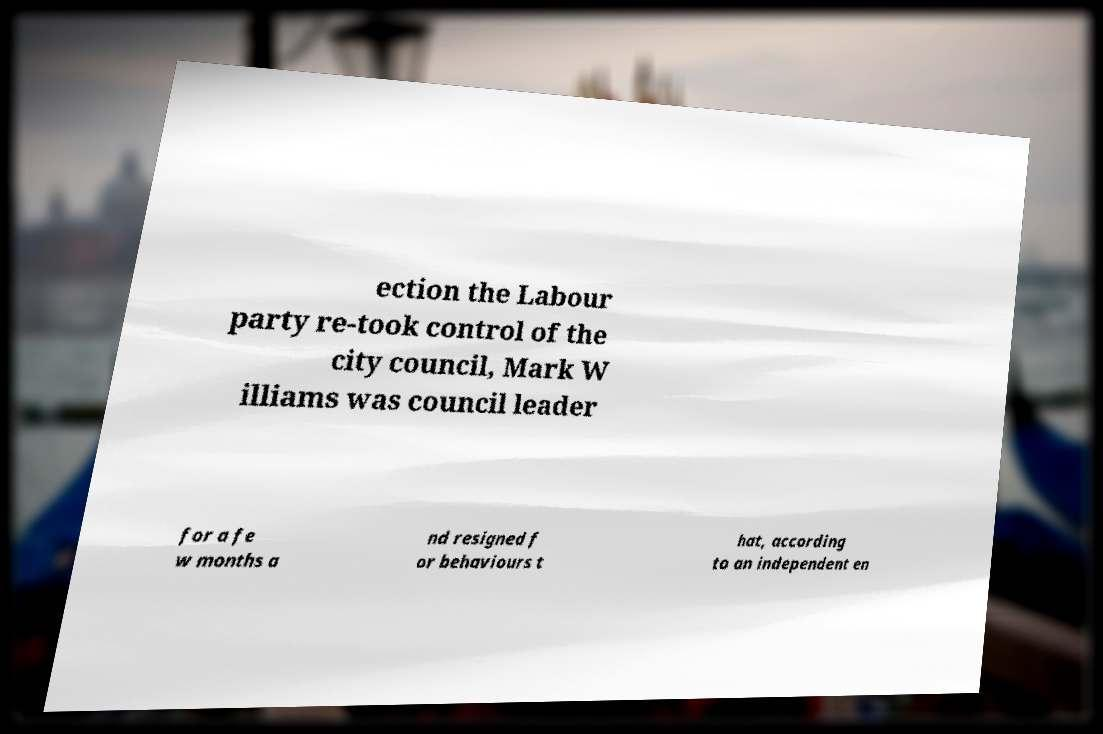What messages or text are displayed in this image? I need them in a readable, typed format. ection the Labour party re-took control of the city council, Mark W illiams was council leader for a fe w months a nd resigned f or behaviours t hat, according to an independent en 